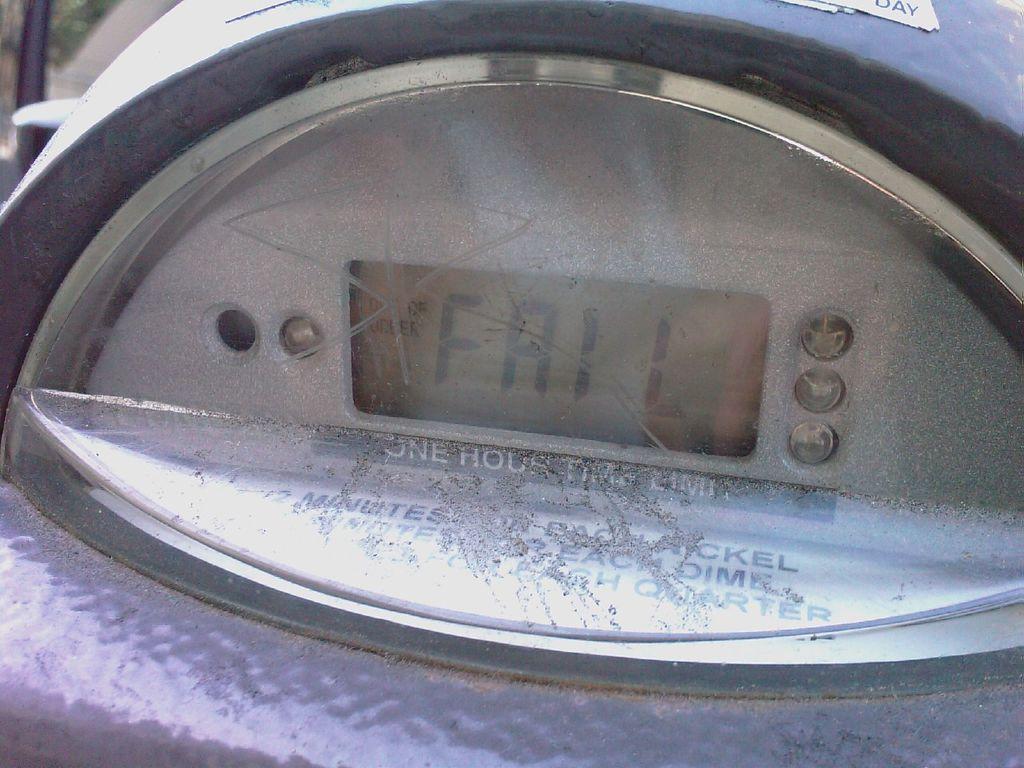What is on the meter?
Ensure brevity in your answer.  Fail. 